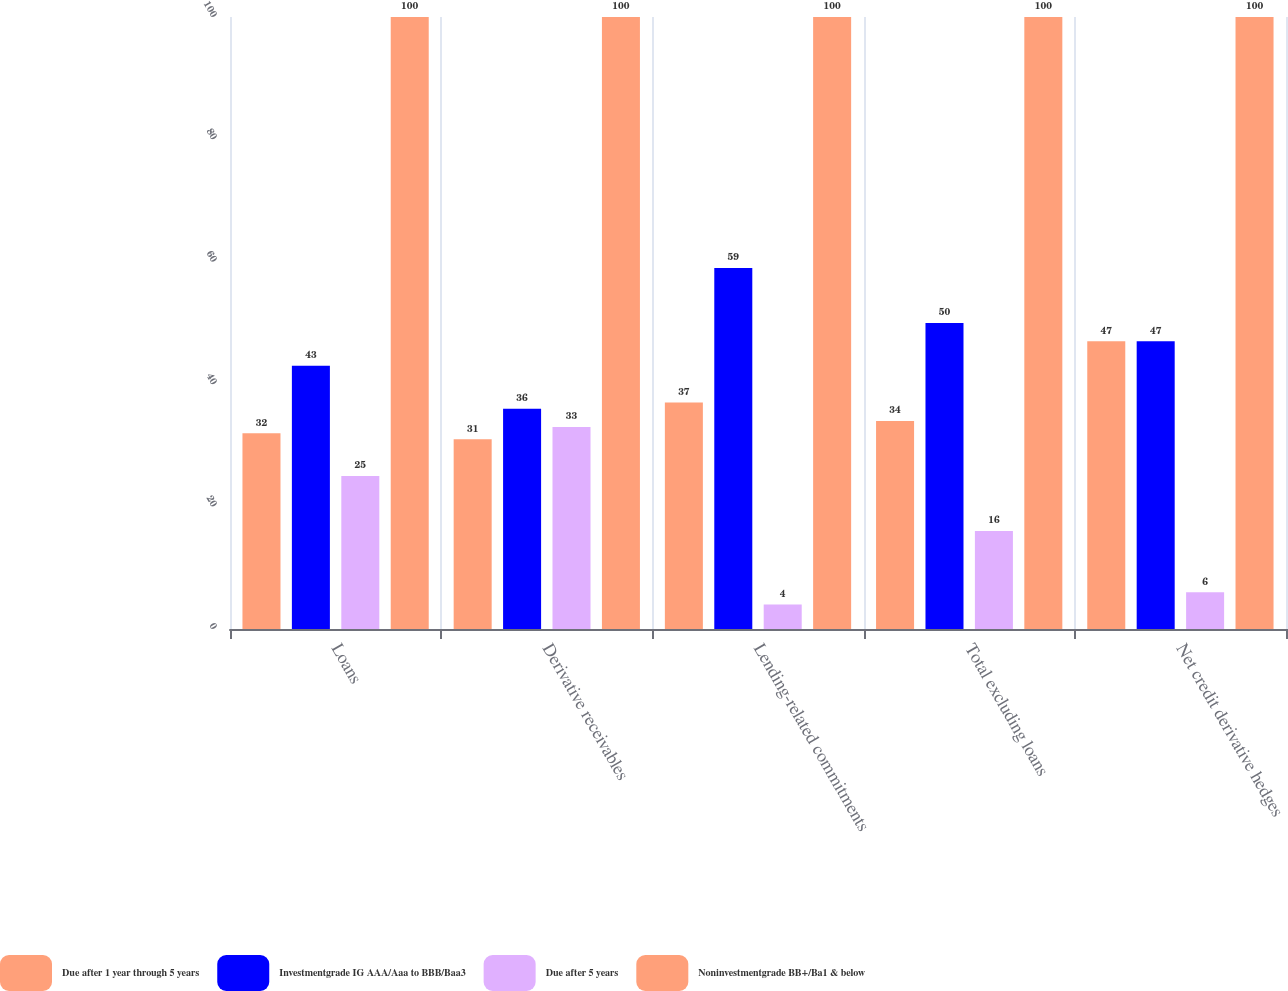<chart> <loc_0><loc_0><loc_500><loc_500><stacked_bar_chart><ecel><fcel>Loans<fcel>Derivative receivables<fcel>Lending-related commitments<fcel>Total excluding loans<fcel>Net credit derivative hedges<nl><fcel>Due after 1 year through 5 years<fcel>32<fcel>31<fcel>37<fcel>34<fcel>47<nl><fcel>Investmentgrade IG AAA/Aaa to BBB/Baa3<fcel>43<fcel>36<fcel>59<fcel>50<fcel>47<nl><fcel>Due after 5 years<fcel>25<fcel>33<fcel>4<fcel>16<fcel>6<nl><fcel>Noninvestmentgrade BB+/Ba1 & below<fcel>100<fcel>100<fcel>100<fcel>100<fcel>100<nl></chart> 